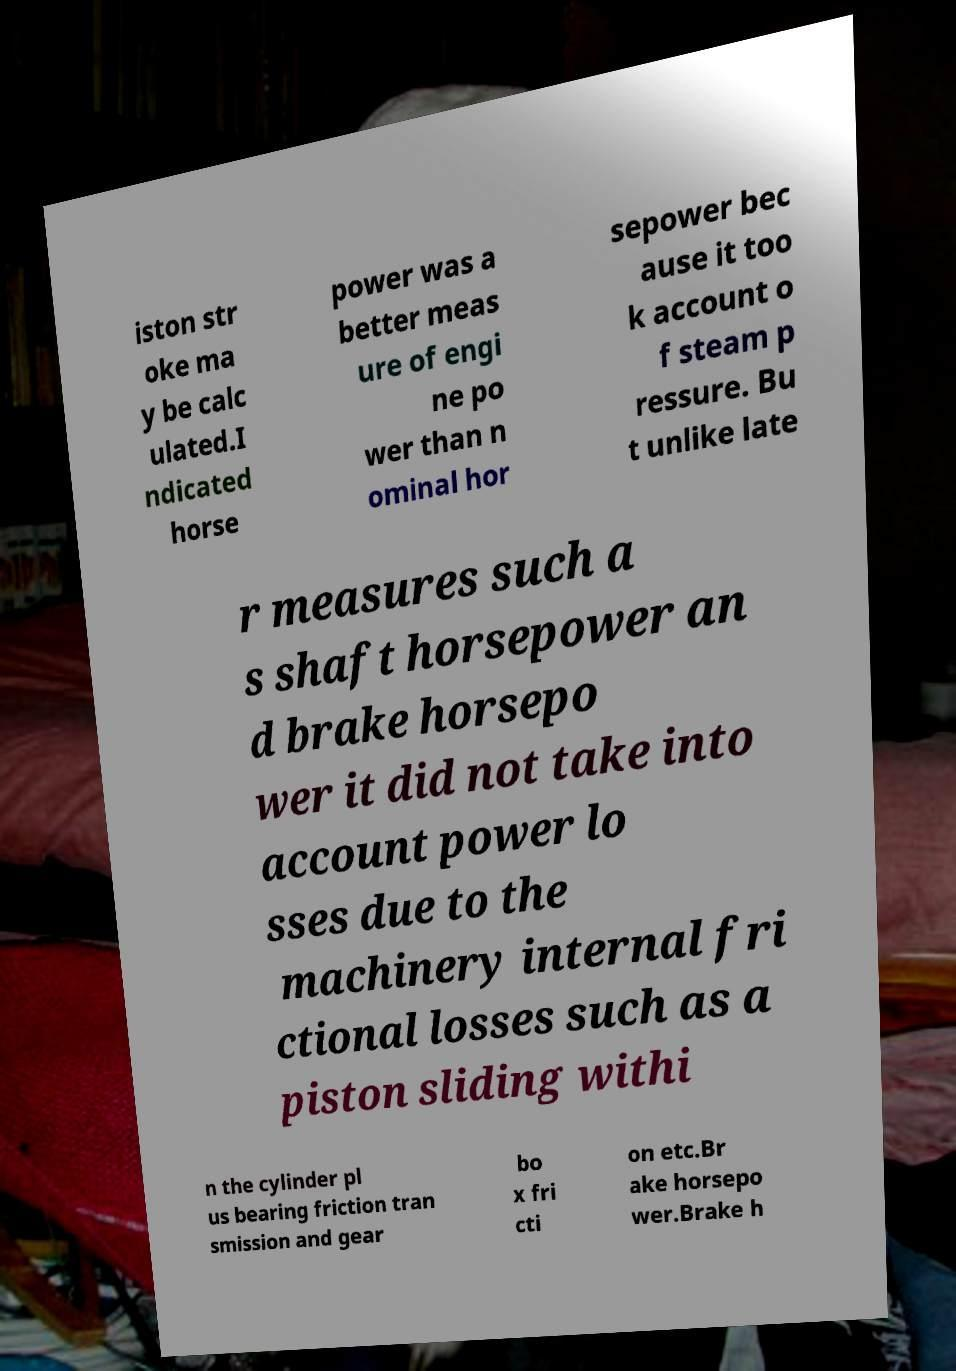For documentation purposes, I need the text within this image transcribed. Could you provide that? iston str oke ma y be calc ulated.I ndicated horse power was a better meas ure of engi ne po wer than n ominal hor sepower bec ause it too k account o f steam p ressure. Bu t unlike late r measures such a s shaft horsepower an d brake horsepo wer it did not take into account power lo sses due to the machinery internal fri ctional losses such as a piston sliding withi n the cylinder pl us bearing friction tran smission and gear bo x fri cti on etc.Br ake horsepo wer.Brake h 